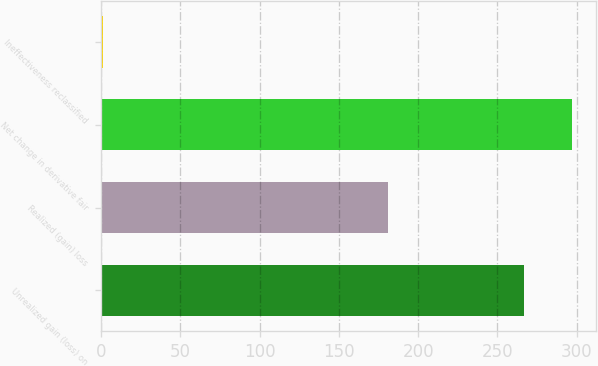Convert chart to OTSL. <chart><loc_0><loc_0><loc_500><loc_500><bar_chart><fcel>Unrealized gain (loss) on<fcel>Realized (gain) loss<fcel>Net change in derivative fair<fcel>Ineffectiveness reclassified<nl><fcel>267<fcel>181<fcel>297<fcel>1<nl></chart> 